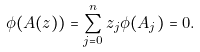<formula> <loc_0><loc_0><loc_500><loc_500>\phi ( A ( z ) ) = \sum _ { j = 0 } ^ { n } z _ { j } \phi ( A _ { j } ) = 0 .</formula> 